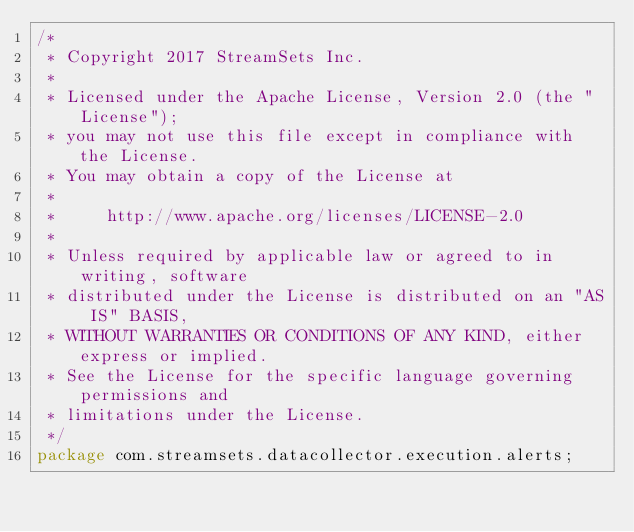<code> <loc_0><loc_0><loc_500><loc_500><_Java_>/*
 * Copyright 2017 StreamSets Inc.
 *
 * Licensed under the Apache License, Version 2.0 (the "License");
 * you may not use this file except in compliance with the License.
 * You may obtain a copy of the License at
 *
 *     http://www.apache.org/licenses/LICENSE-2.0
 *
 * Unless required by applicable law or agreed to in writing, software
 * distributed under the License is distributed on an "AS IS" BASIS,
 * WITHOUT WARRANTIES OR CONDITIONS OF ANY KIND, either express or implied.
 * See the License for the specific language governing permissions and
 * limitations under the License.
 */
package com.streamsets.datacollector.execution.alerts;
</code> 